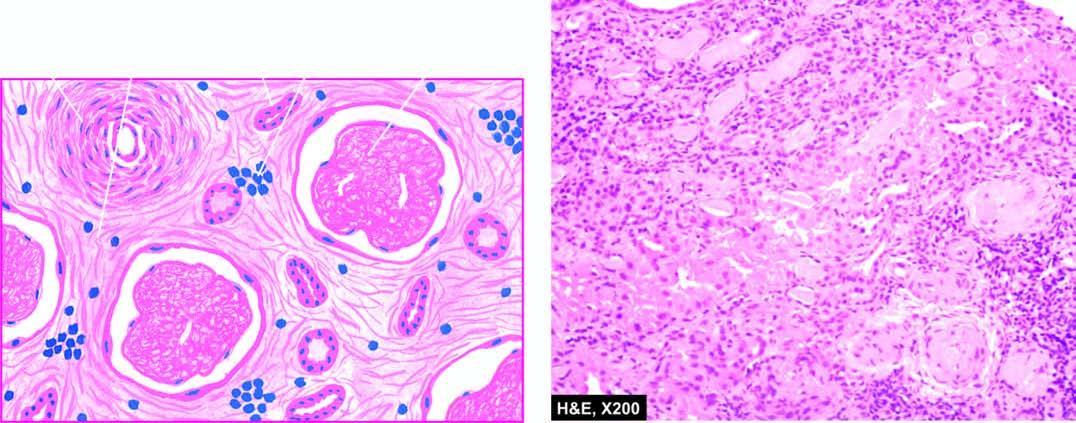what are hyalinised and thickened while the interstitium shows fine fibrosis and a few chronic inflammatory cells?
Answer the question using a single word or phrase. Blood vessels in the interstitium 